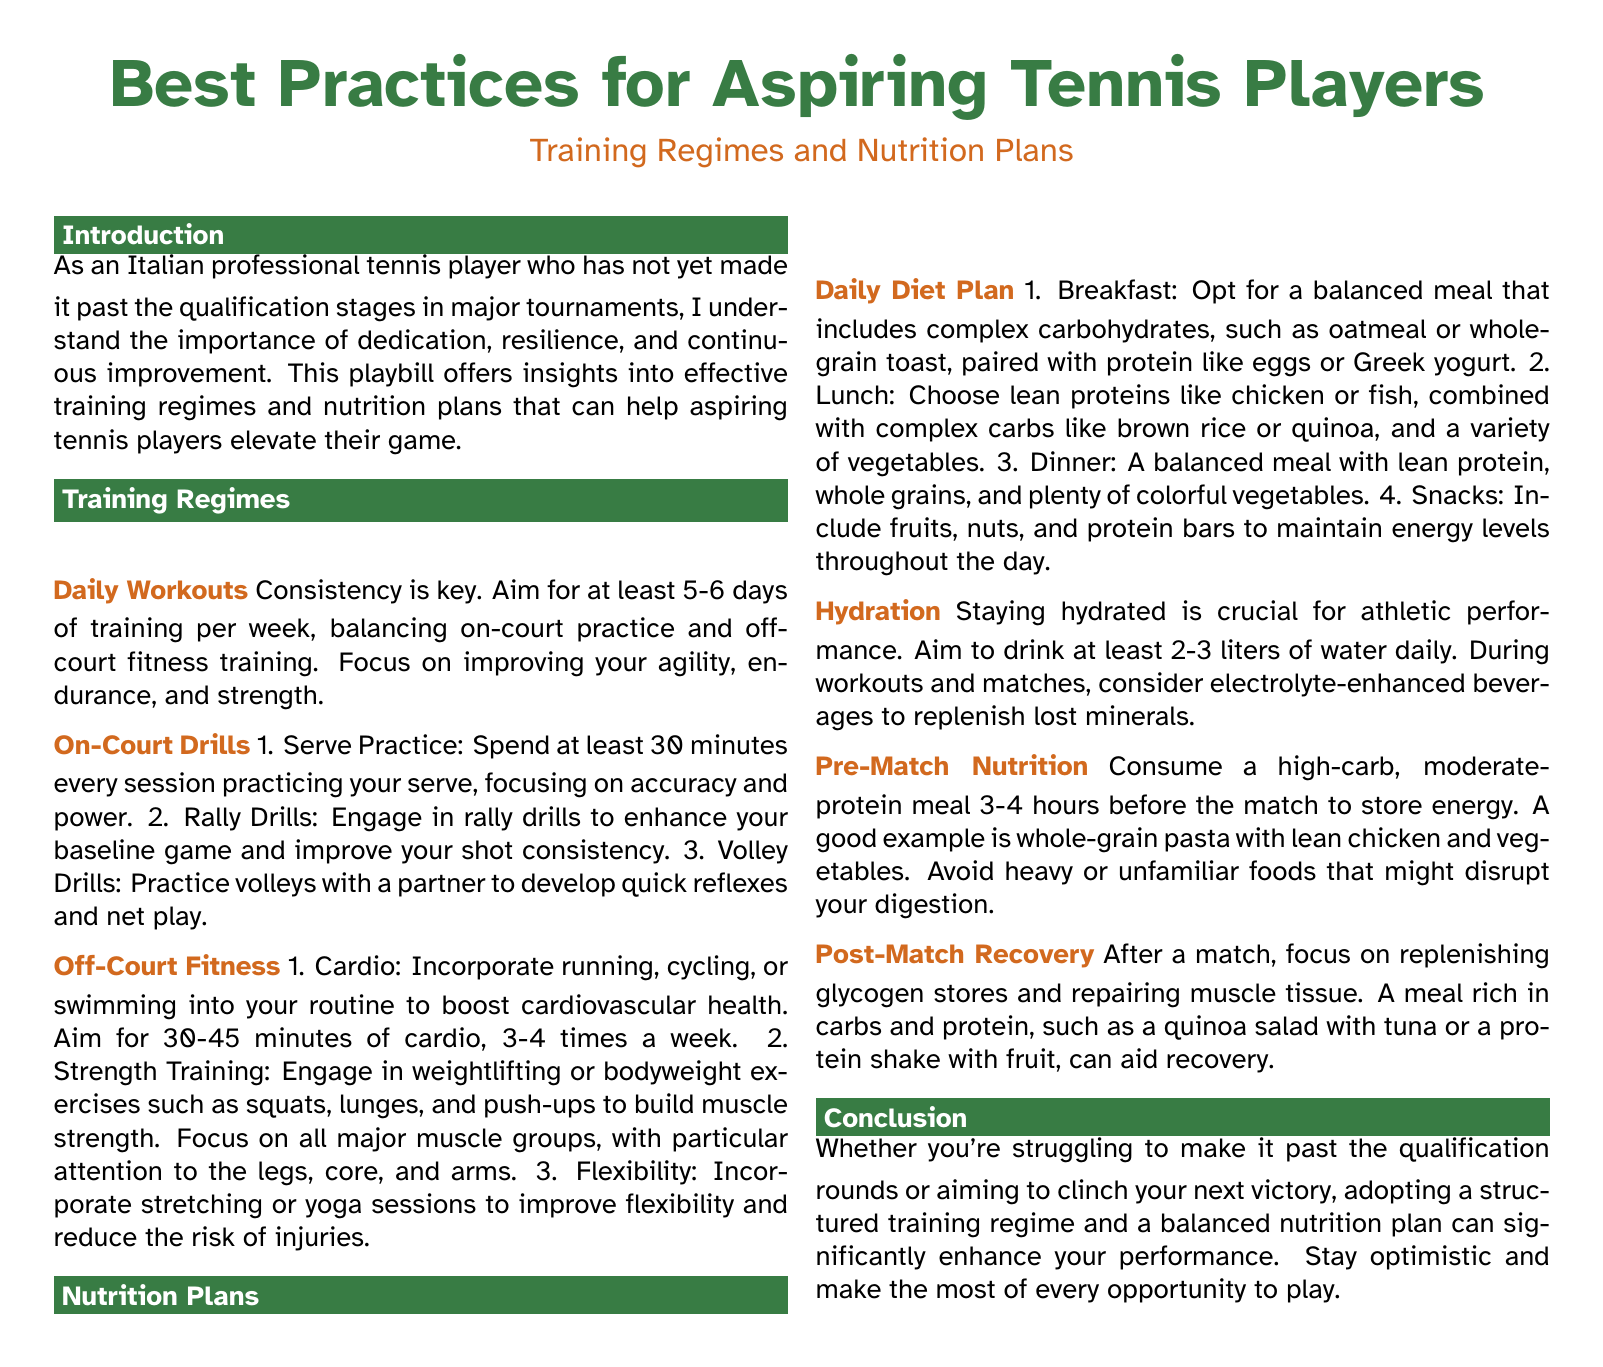What is the main focus of the document? The main focus of the document is on best practices for aspiring tennis players regarding training regimes and nutrition plans.
Answer: best practices for aspiring tennis players How many days per week should aspiring players train? The document states that aspiring players should aim for at least 5-6 days of training per week.
Answer: 5-6 days What type of cardio activities are suggested? Cardio activities suggested include running, cycling, or swimming.
Answer: running, cycling, or swimming What is a recommended pre-match meal? The document recommends a high-carb, moderate-protein meal, such as whole-grain pasta with lean chicken and vegetables, to be consumed before a match.
Answer: whole-grain pasta with lean chicken and vegetables How much water should players drink daily? Players are advised to drink at least 2-3 liters of water daily.
Answer: 2-3 liters What should be included in a balanced breakfast? A balanced breakfast should include complex carbohydrates and protein, such as oatmeal or whole-grain toast and eggs or Greek yogurt.
Answer: oatmeal or whole-grain toast and eggs or Greek yogurt What is the purpose of post-match nutrition? The purpose of post-match nutrition is to replenish glycogen stores and repair muscle tissue.
Answer: replenish glycogen stores and repair muscle tissue What is emphasized in the conclusion? The conclusion emphasizes adopting a structured training regime and a balanced nutrition plan to enhance performance.
Answer: adopting a structured training regime and a balanced nutrition plan 